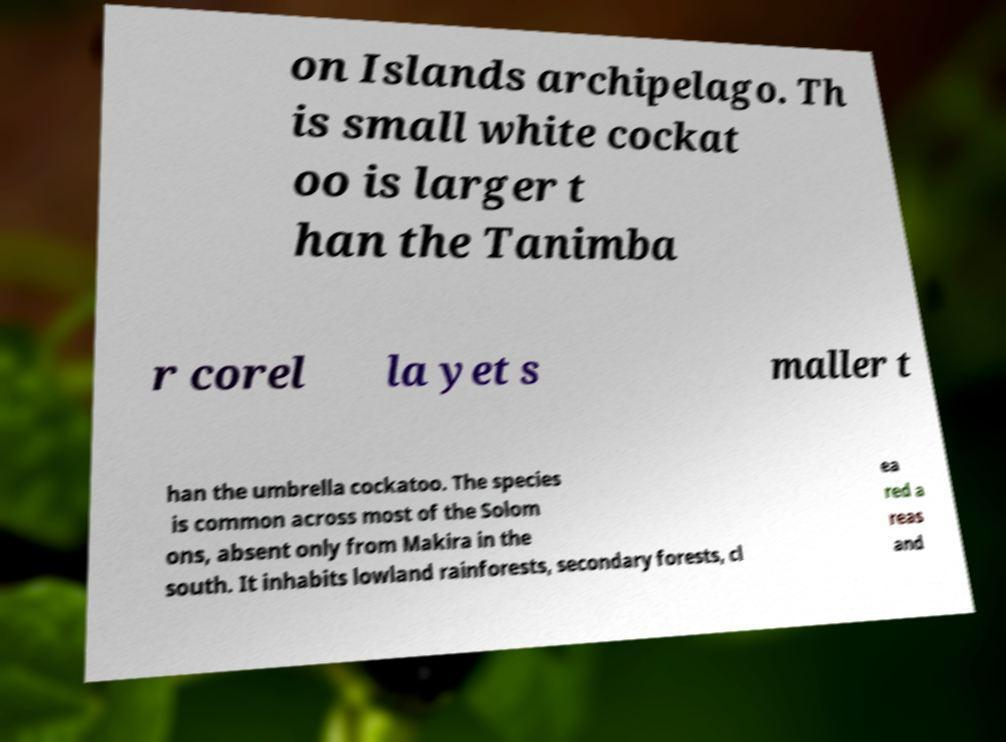Can you read and provide the text displayed in the image?This photo seems to have some interesting text. Can you extract and type it out for me? on Islands archipelago. Th is small white cockat oo is larger t han the Tanimba r corel la yet s maller t han the umbrella cockatoo. The species is common across most of the Solom ons, absent only from Makira in the south. It inhabits lowland rainforests, secondary forests, cl ea red a reas and 